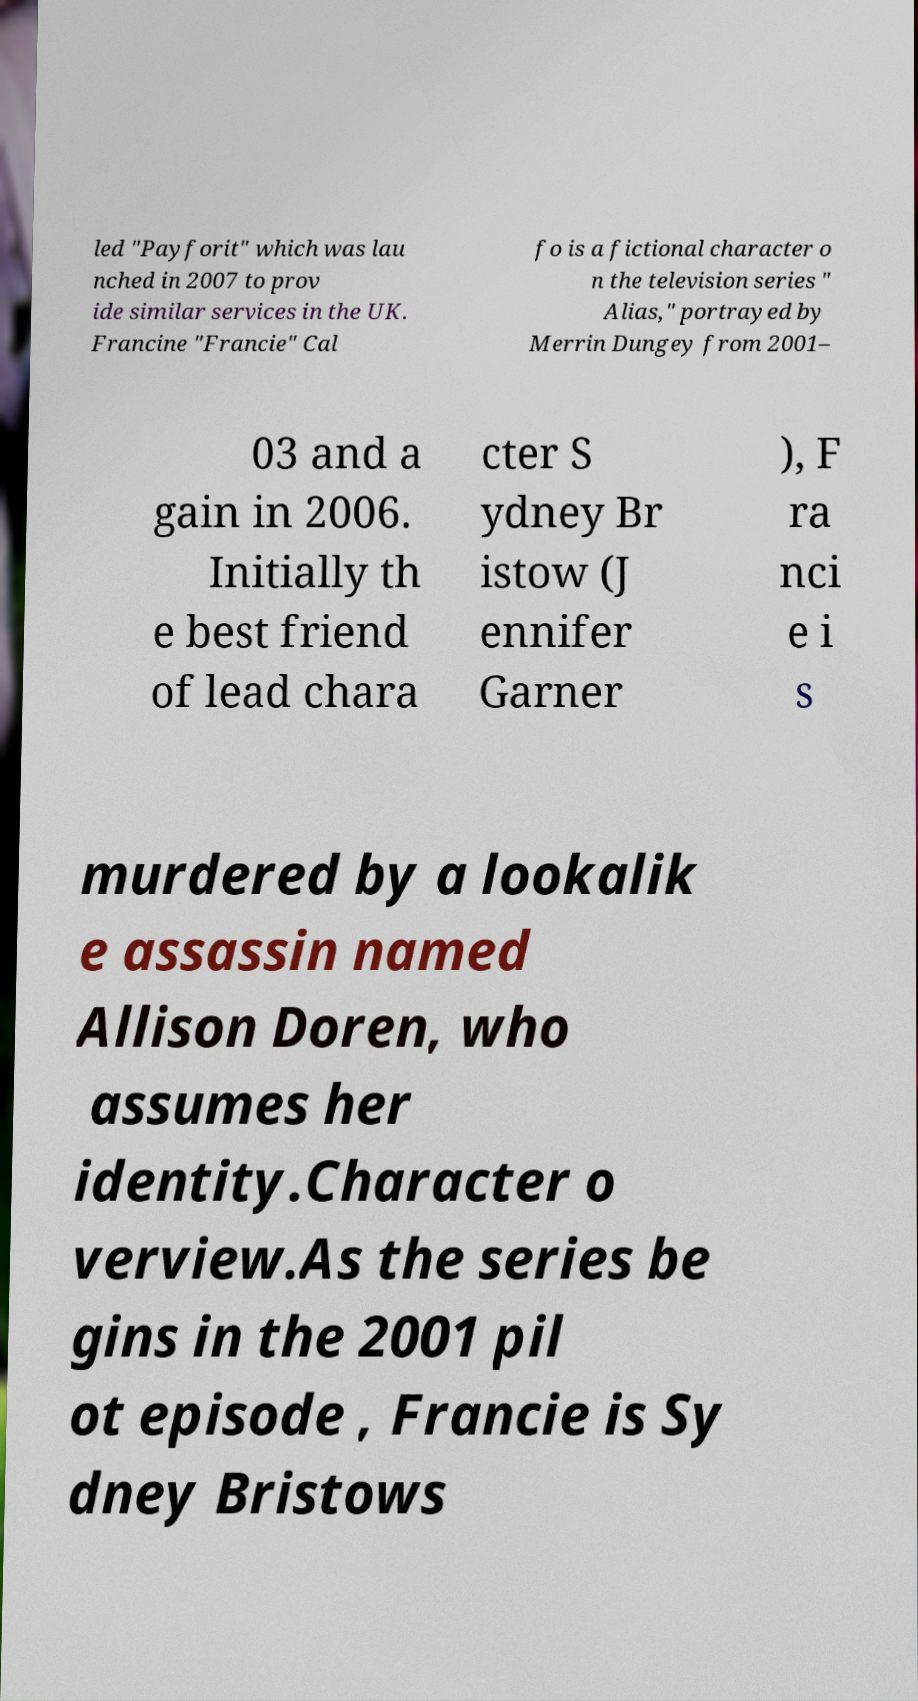Please identify and transcribe the text found in this image. led "Payforit" which was lau nched in 2007 to prov ide similar services in the UK. Francine "Francie" Cal fo is a fictional character o n the television series " Alias," portrayed by Merrin Dungey from 2001– 03 and a gain in 2006. Initially th e best friend of lead chara cter S ydney Br istow (J ennifer Garner ), F ra nci e i s murdered by a lookalik e assassin named Allison Doren, who assumes her identity.Character o verview.As the series be gins in the 2001 pil ot episode , Francie is Sy dney Bristows 